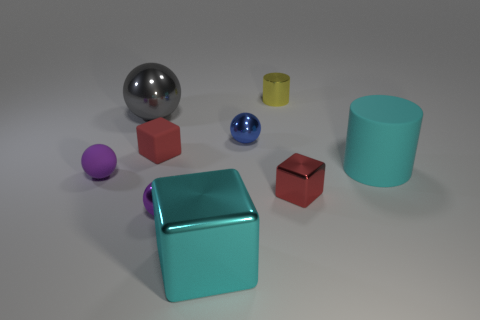What is the shape of the object that is the same color as the large block?
Your answer should be compact. Cylinder. How many other things are made of the same material as the gray object?
Give a very brief answer. 5. Do the matte block and the matte cylinder have the same color?
Offer a terse response. No. Is the number of gray objects right of the blue metallic sphere less than the number of cyan rubber objects in front of the tiny cylinder?
Provide a succinct answer. Yes. There is a tiny shiny thing that is the same shape as the red matte thing; what color is it?
Ensure brevity in your answer.  Red. Do the metallic sphere in front of the red metallic block and the matte cylinder have the same size?
Provide a succinct answer. No. Is the number of yellow things that are in front of the cyan cylinder less than the number of purple metallic objects?
Give a very brief answer. Yes. What size is the red object that is on the left side of the small metallic object that is behind the blue ball?
Your answer should be compact. Small. Is there anything else that has the same shape as the purple shiny thing?
Provide a succinct answer. Yes. Are there fewer cyan cylinders than large cyan matte spheres?
Offer a terse response. No. 